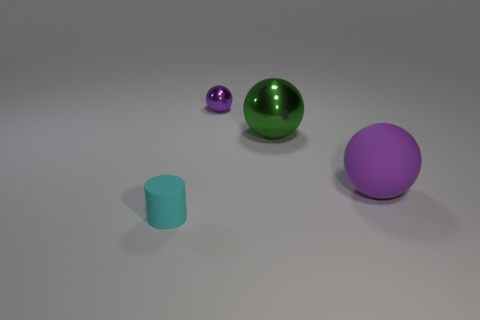Add 3 big metal objects. How many objects exist? 7 Subtract all purple matte balls. How many balls are left? 2 Subtract all cylinders. How many objects are left? 3 Subtract all green spheres. How many spheres are left? 2 Subtract all red spheres. How many blue cylinders are left? 0 Subtract all big cyan metal spheres. Subtract all tiny cyan things. How many objects are left? 3 Add 2 purple matte spheres. How many purple matte spheres are left? 3 Add 4 tiny shiny balls. How many tiny shiny balls exist? 5 Subtract 0 cyan spheres. How many objects are left? 4 Subtract all purple balls. Subtract all yellow blocks. How many balls are left? 1 